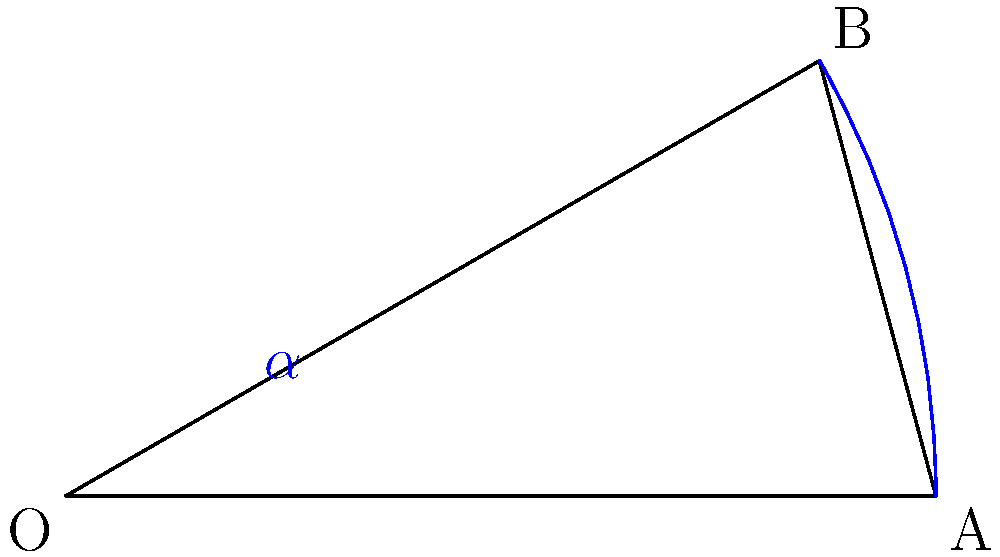In a responsive web layout, you need to rotate an element by 30 degrees clockwise using CSS transforms. What is the correct CSS property and value to achieve this rotation? To rotate an element in CSS, we use the `transform` property with the `rotate()` function. Here's the step-by-step explanation:

1. The `transform` property is used to apply 2D or 3D transformations to an element.
2. The `rotate()` function is one of the transform functions that rotates an element around a fixed point (by default, the center of the element).
3. The rotation angle is specified as a parameter to the `rotate()` function.
4. Positive values rotate the element clockwise, while negative values rotate it counterclockwise.
5. The angle can be specified in degrees (deg), radians (rad), or turns.
6. In this case, we need to rotate the element 30 degrees clockwise.
7. Therefore, the correct CSS property and value would be: `transform: rotate(30deg);`

Note: In the diagram, $\alpha$ represents the 30-degree angle of rotation, and the red mark indicates the right angle formed at the origin before rotation.
Answer: transform: rotate(30deg); 